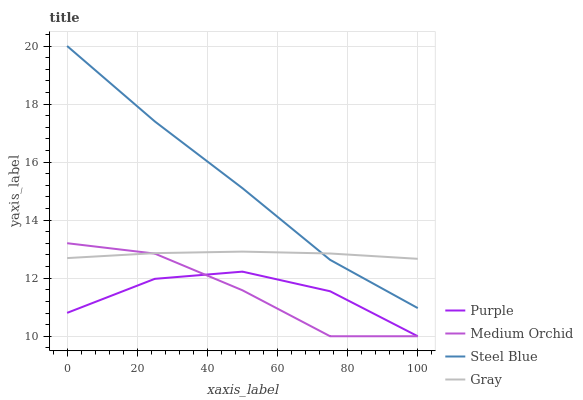Does Medium Orchid have the minimum area under the curve?
Answer yes or no. Yes. Does Steel Blue have the maximum area under the curve?
Answer yes or no. Yes. Does Gray have the minimum area under the curve?
Answer yes or no. No. Does Gray have the maximum area under the curve?
Answer yes or no. No. Is Gray the smoothest?
Answer yes or no. Yes. Is Medium Orchid the roughest?
Answer yes or no. Yes. Is Medium Orchid the smoothest?
Answer yes or no. No. Is Gray the roughest?
Answer yes or no. No. Does Purple have the lowest value?
Answer yes or no. Yes. Does Gray have the lowest value?
Answer yes or no. No. Does Steel Blue have the highest value?
Answer yes or no. Yes. Does Gray have the highest value?
Answer yes or no. No. Is Purple less than Gray?
Answer yes or no. Yes. Is Steel Blue greater than Purple?
Answer yes or no. Yes. Does Medium Orchid intersect Purple?
Answer yes or no. Yes. Is Medium Orchid less than Purple?
Answer yes or no. No. Is Medium Orchid greater than Purple?
Answer yes or no. No. Does Purple intersect Gray?
Answer yes or no. No. 